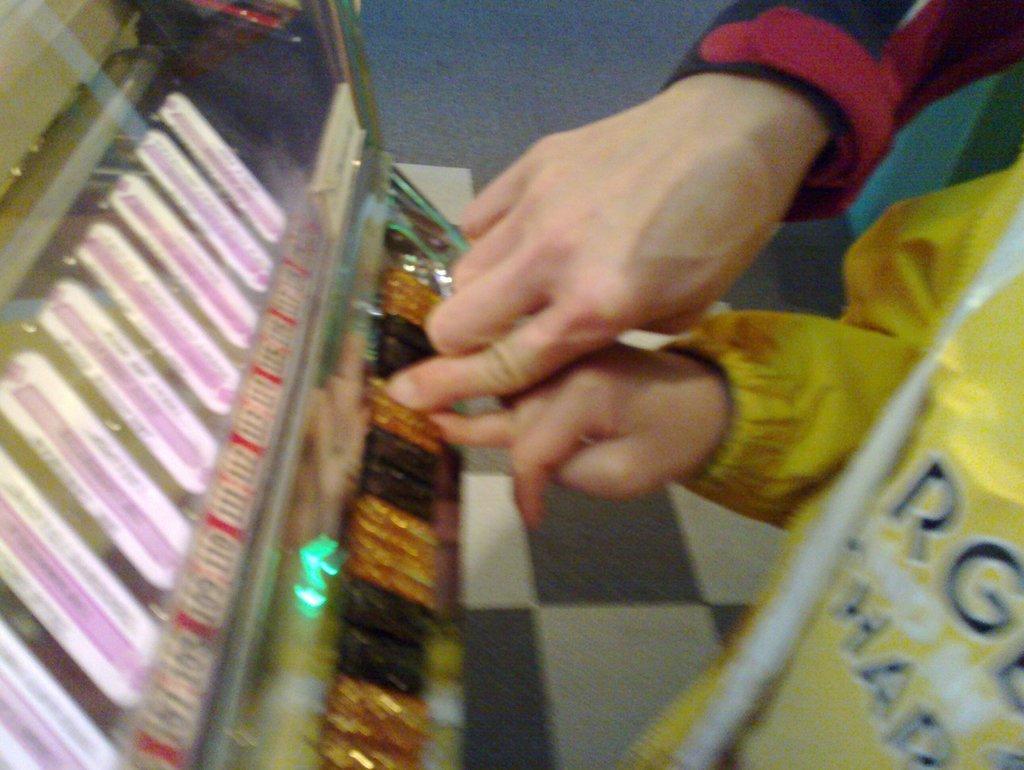Please provide a concise description of this image. In this picture we can see hands of two persons, in front of them we can see a machine. 